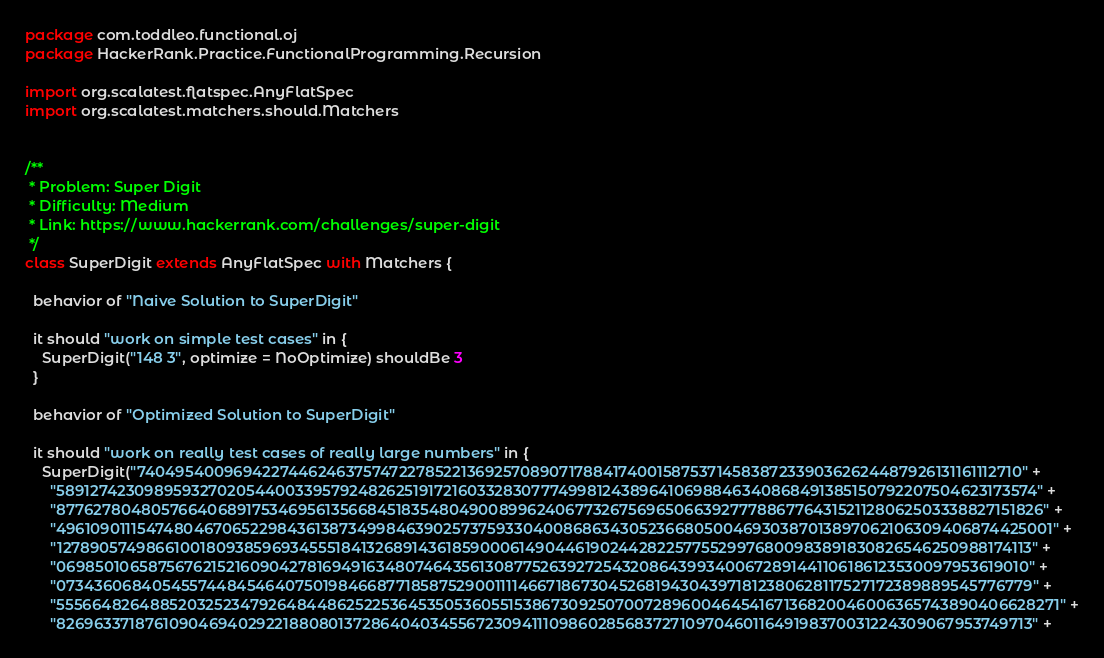Convert code to text. <code><loc_0><loc_0><loc_500><loc_500><_Scala_>package com.toddleo.functional.oj
package HackerRank.Practice.FunctionalProgramming.Recursion

import org.scalatest.flatspec.AnyFlatSpec
import org.scalatest.matchers.should.Matchers


/**
 * Problem: Super Digit
 * Difficulty: Medium
 * Link: https://www.hackerrank.com/challenges/super-digit
 */
class SuperDigit extends AnyFlatSpec with Matchers {

  behavior of "Naive Solution to SuperDigit"

  it should "work on simple test cases" in {
    SuperDigit("148 3", optimize = NoOptimize) shouldBe 3
  }

  behavior of "Optimized Solution to SuperDigit"

  it should "work on really test cases of really large numbers" in {
    SuperDigit("7404954009694227446246375747227852213692570890717884174001587537145838723390362624487926131161112710" +
      "5891274230989593270205440033957924826251917216033283077749981243896410698846340868491385150792207504623173574" +
      "8776278048057664068917534695613566845183548049008996240677326756965066392777886776431521128062503338827151826" +
      "4961090111547480467065229843613873499846390257375933040086863430523668050046930387013897062106309406874425001" +
      "1278905749866100180938596934555184132689143618590006149044619024428225775529976800983891830826546250988174113" +
      "0698501065875676215216090427816949163480746435613087752639272543208643993400672891441106186123530097953619010" +
      "0734360684054557448454640750198466877185875290011114667186730452681943043971812380628117527172389889545776779" +
      "5556648264885203252347926484486252253645350536055153867309250700728960046454167136820046006365743890406628271" +
      "8269633718761090469402922188080137286404034556723094111098602856837271097046011649198370031224309067953749713" +</code> 